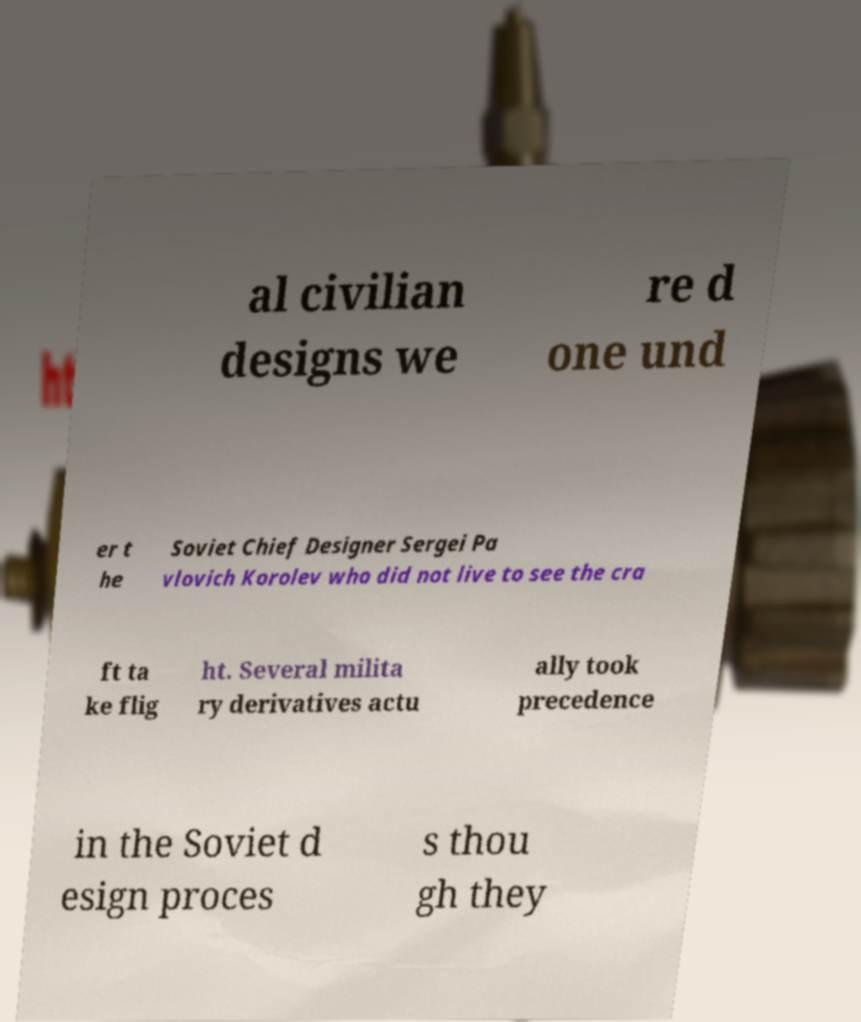What messages or text are displayed in this image? I need them in a readable, typed format. al civilian designs we re d one und er t he Soviet Chief Designer Sergei Pa vlovich Korolev who did not live to see the cra ft ta ke flig ht. Several milita ry derivatives actu ally took precedence in the Soviet d esign proces s thou gh they 